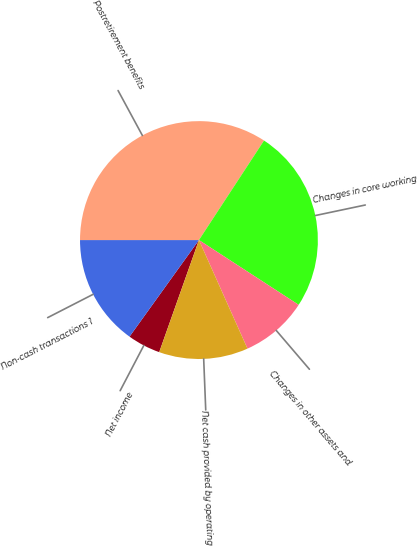<chart> <loc_0><loc_0><loc_500><loc_500><pie_chart><fcel>Net income<fcel>Non-cash transactions 1<fcel>Postretirement benefits<fcel>Changes in core working<fcel>Changes in other assets and<fcel>Net cash provided by operating<nl><fcel>4.5%<fcel>15.08%<fcel>34.22%<fcel>24.95%<fcel>9.14%<fcel>12.11%<nl></chart> 